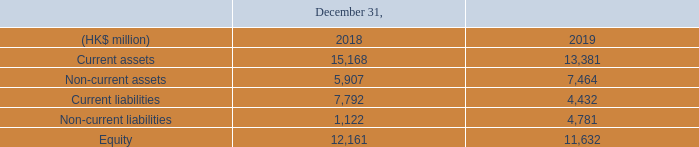Summarized 100% statement of financial position information for ASMPT equity method investment excluding basis adjustments (foreign currency exchange rate per December 31, 2019 was 1 HK$: €0.11432 for December 31, 2018: 1 HK$: €0.11151).
Equity of ASMPT per December 31, 2019 translated into euros at a rate of 0.11432 was €1,329 million (our 25.19% share: €335 million).
The ASMPT Board is responsible for ongoing monitoring of the performance of the Back-end activities. The actual results of the Back-end operating unit are discussed with the ASMPT Audit Committee, which includes the representative of ASMI. The ASMI representative reports to the ASMI Management Board and the Audit Committee of ASMI on a quarterly basis.
Our share of income taxes incurred directly by the associates is reported in result from investments in associates and as such is not included in income taxes in our consolidated financial statements.
What is the ASMPT Board responsible for?  Ongoing monitoring of the performance of the back-end activities. What are the years included in the table? 2018, 2019. What is the current assets in 2018?
Answer scale should be: million. 15,168. What is the current liability to current assets ratio for 2019?  4,432 / 13,381 
Answer: 0.33. What is the change in current liability to current assets ratio from 2018 to 2019?  (4,432 / 13,381)-(7,792/ 15,168) 
Answer: -0.18. Which year has the highest equity to total asset ratio? 2018:(12,161/( 5,907 + 15,168 )=0.58); 2019:( 11,632/(13,381+7,464)=0.56)
Answer: 2018. 